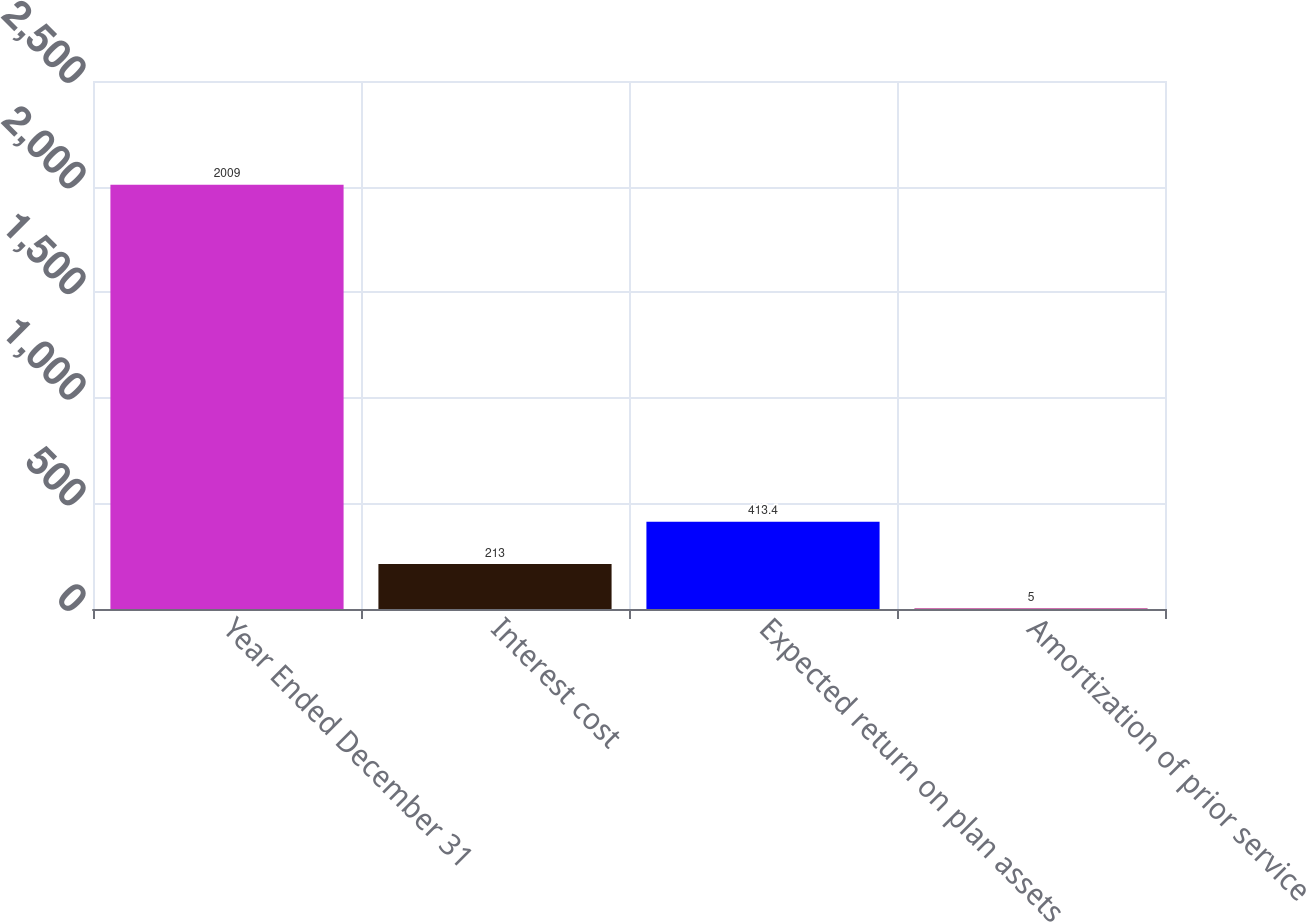Convert chart to OTSL. <chart><loc_0><loc_0><loc_500><loc_500><bar_chart><fcel>Year Ended December 31<fcel>Interest cost<fcel>Expected return on plan assets<fcel>Amortization of prior service<nl><fcel>2009<fcel>213<fcel>413.4<fcel>5<nl></chart> 